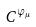Convert formula to latex. <formula><loc_0><loc_0><loc_500><loc_500>C ^ { \varphi _ { \mu } }</formula> 